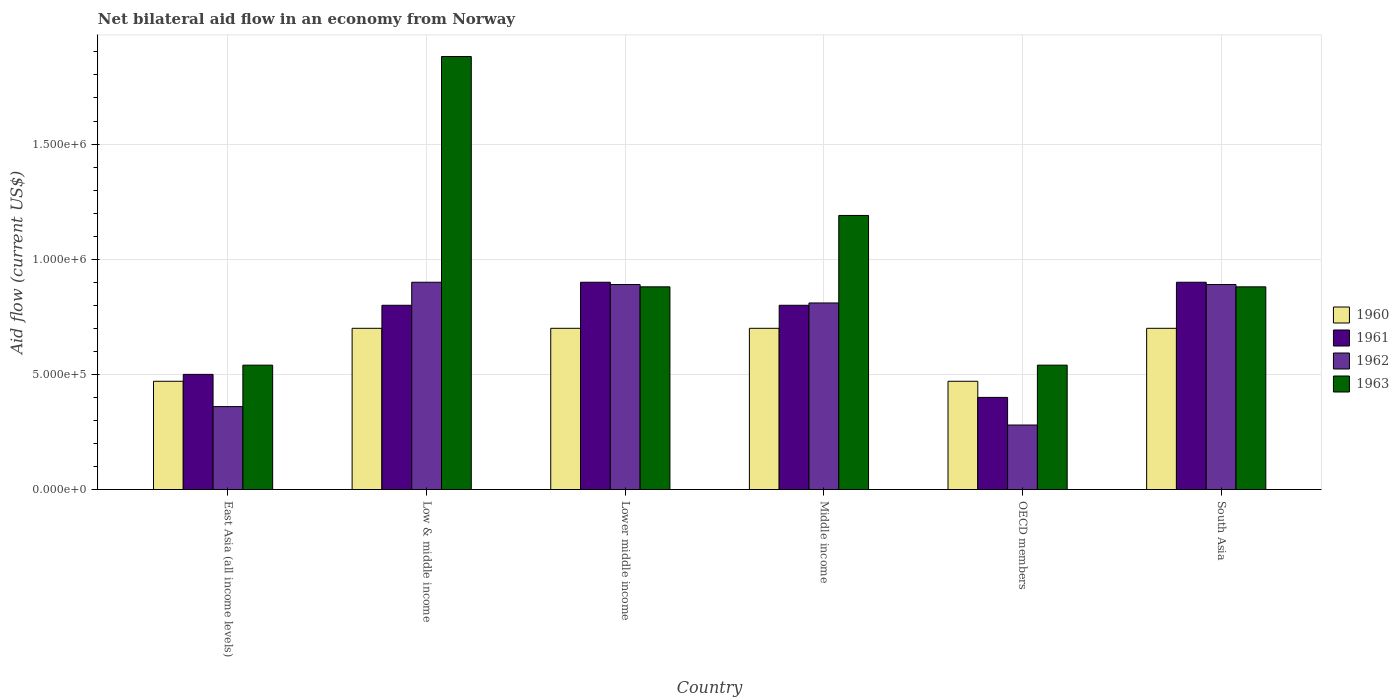How many different coloured bars are there?
Keep it short and to the point. 4. Are the number of bars on each tick of the X-axis equal?
Your answer should be very brief. Yes. What is the label of the 1st group of bars from the left?
Offer a very short reply. East Asia (all income levels). What is the net bilateral aid flow in 1961 in Lower middle income?
Ensure brevity in your answer.  9.00e+05. Across all countries, what is the maximum net bilateral aid flow in 1963?
Keep it short and to the point. 1.88e+06. In which country was the net bilateral aid flow in 1960 minimum?
Your answer should be very brief. East Asia (all income levels). What is the total net bilateral aid flow in 1962 in the graph?
Your answer should be compact. 4.13e+06. What is the difference between the net bilateral aid flow in 1962 in Lower middle income and that in South Asia?
Offer a terse response. 0. What is the average net bilateral aid flow in 1963 per country?
Offer a very short reply. 9.85e+05. What is the difference between the net bilateral aid flow of/in 1962 and net bilateral aid flow of/in 1963 in Middle income?
Your answer should be compact. -3.80e+05. What is the ratio of the net bilateral aid flow in 1962 in East Asia (all income levels) to that in South Asia?
Your answer should be compact. 0.4. What is the difference between the highest and the second highest net bilateral aid flow in 1963?
Your answer should be compact. 6.90e+05. What is the difference between the highest and the lowest net bilateral aid flow in 1960?
Offer a very short reply. 2.30e+05. Is the sum of the net bilateral aid flow in 1961 in Low & middle income and South Asia greater than the maximum net bilateral aid flow in 1963 across all countries?
Ensure brevity in your answer.  No. Is it the case that in every country, the sum of the net bilateral aid flow in 1961 and net bilateral aid flow in 1960 is greater than the sum of net bilateral aid flow in 1963 and net bilateral aid flow in 1962?
Offer a very short reply. No. What does the 4th bar from the left in Middle income represents?
Your response must be concise. 1963. How many bars are there?
Your answer should be compact. 24. How many countries are there in the graph?
Your response must be concise. 6. What is the difference between two consecutive major ticks on the Y-axis?
Provide a short and direct response. 5.00e+05. Does the graph contain any zero values?
Keep it short and to the point. No. How many legend labels are there?
Provide a short and direct response. 4. How are the legend labels stacked?
Your response must be concise. Vertical. What is the title of the graph?
Your response must be concise. Net bilateral aid flow in an economy from Norway. Does "2015" appear as one of the legend labels in the graph?
Your answer should be very brief. No. What is the label or title of the X-axis?
Provide a succinct answer. Country. What is the label or title of the Y-axis?
Provide a short and direct response. Aid flow (current US$). What is the Aid flow (current US$) in 1963 in East Asia (all income levels)?
Offer a terse response. 5.40e+05. What is the Aid flow (current US$) of 1962 in Low & middle income?
Ensure brevity in your answer.  9.00e+05. What is the Aid flow (current US$) of 1963 in Low & middle income?
Your answer should be very brief. 1.88e+06. What is the Aid flow (current US$) in 1962 in Lower middle income?
Keep it short and to the point. 8.90e+05. What is the Aid flow (current US$) of 1963 in Lower middle income?
Provide a succinct answer. 8.80e+05. What is the Aid flow (current US$) of 1961 in Middle income?
Your response must be concise. 8.00e+05. What is the Aid flow (current US$) of 1962 in Middle income?
Offer a terse response. 8.10e+05. What is the Aid flow (current US$) of 1963 in Middle income?
Offer a very short reply. 1.19e+06. What is the Aid flow (current US$) in 1963 in OECD members?
Your answer should be compact. 5.40e+05. What is the Aid flow (current US$) in 1962 in South Asia?
Offer a very short reply. 8.90e+05. What is the Aid flow (current US$) of 1963 in South Asia?
Ensure brevity in your answer.  8.80e+05. Across all countries, what is the maximum Aid flow (current US$) in 1961?
Provide a short and direct response. 9.00e+05. Across all countries, what is the maximum Aid flow (current US$) of 1962?
Offer a very short reply. 9.00e+05. Across all countries, what is the maximum Aid flow (current US$) of 1963?
Provide a succinct answer. 1.88e+06. Across all countries, what is the minimum Aid flow (current US$) of 1963?
Ensure brevity in your answer.  5.40e+05. What is the total Aid flow (current US$) of 1960 in the graph?
Give a very brief answer. 3.74e+06. What is the total Aid flow (current US$) of 1961 in the graph?
Your answer should be very brief. 4.30e+06. What is the total Aid flow (current US$) in 1962 in the graph?
Provide a succinct answer. 4.13e+06. What is the total Aid flow (current US$) of 1963 in the graph?
Provide a succinct answer. 5.91e+06. What is the difference between the Aid flow (current US$) of 1960 in East Asia (all income levels) and that in Low & middle income?
Offer a terse response. -2.30e+05. What is the difference between the Aid flow (current US$) in 1961 in East Asia (all income levels) and that in Low & middle income?
Your response must be concise. -3.00e+05. What is the difference between the Aid flow (current US$) in 1962 in East Asia (all income levels) and that in Low & middle income?
Offer a terse response. -5.40e+05. What is the difference between the Aid flow (current US$) in 1963 in East Asia (all income levels) and that in Low & middle income?
Provide a succinct answer. -1.34e+06. What is the difference between the Aid flow (current US$) of 1961 in East Asia (all income levels) and that in Lower middle income?
Provide a succinct answer. -4.00e+05. What is the difference between the Aid flow (current US$) in 1962 in East Asia (all income levels) and that in Lower middle income?
Provide a short and direct response. -5.30e+05. What is the difference between the Aid flow (current US$) of 1961 in East Asia (all income levels) and that in Middle income?
Provide a succinct answer. -3.00e+05. What is the difference between the Aid flow (current US$) in 1962 in East Asia (all income levels) and that in Middle income?
Ensure brevity in your answer.  -4.50e+05. What is the difference between the Aid flow (current US$) in 1963 in East Asia (all income levels) and that in Middle income?
Your response must be concise. -6.50e+05. What is the difference between the Aid flow (current US$) in 1960 in East Asia (all income levels) and that in OECD members?
Offer a terse response. 0. What is the difference between the Aid flow (current US$) in 1961 in East Asia (all income levels) and that in OECD members?
Give a very brief answer. 1.00e+05. What is the difference between the Aid flow (current US$) in 1963 in East Asia (all income levels) and that in OECD members?
Provide a succinct answer. 0. What is the difference between the Aid flow (current US$) in 1960 in East Asia (all income levels) and that in South Asia?
Your answer should be very brief. -2.30e+05. What is the difference between the Aid flow (current US$) in 1961 in East Asia (all income levels) and that in South Asia?
Provide a short and direct response. -4.00e+05. What is the difference between the Aid flow (current US$) of 1962 in East Asia (all income levels) and that in South Asia?
Provide a short and direct response. -5.30e+05. What is the difference between the Aid flow (current US$) of 1963 in East Asia (all income levels) and that in South Asia?
Provide a succinct answer. -3.40e+05. What is the difference between the Aid flow (current US$) of 1961 in Low & middle income and that in Lower middle income?
Your answer should be compact. -1.00e+05. What is the difference between the Aid flow (current US$) of 1962 in Low & middle income and that in Lower middle income?
Provide a succinct answer. 10000. What is the difference between the Aid flow (current US$) in 1962 in Low & middle income and that in Middle income?
Your answer should be compact. 9.00e+04. What is the difference between the Aid flow (current US$) of 1963 in Low & middle income and that in Middle income?
Your answer should be very brief. 6.90e+05. What is the difference between the Aid flow (current US$) of 1962 in Low & middle income and that in OECD members?
Provide a short and direct response. 6.20e+05. What is the difference between the Aid flow (current US$) in 1963 in Low & middle income and that in OECD members?
Your answer should be very brief. 1.34e+06. What is the difference between the Aid flow (current US$) in 1961 in Low & middle income and that in South Asia?
Provide a succinct answer. -1.00e+05. What is the difference between the Aid flow (current US$) of 1963 in Low & middle income and that in South Asia?
Keep it short and to the point. 1.00e+06. What is the difference between the Aid flow (current US$) in 1960 in Lower middle income and that in Middle income?
Keep it short and to the point. 0. What is the difference between the Aid flow (current US$) in 1962 in Lower middle income and that in Middle income?
Provide a succinct answer. 8.00e+04. What is the difference between the Aid flow (current US$) in 1963 in Lower middle income and that in Middle income?
Ensure brevity in your answer.  -3.10e+05. What is the difference between the Aid flow (current US$) of 1961 in Lower middle income and that in OECD members?
Provide a succinct answer. 5.00e+05. What is the difference between the Aid flow (current US$) in 1962 in Lower middle income and that in OECD members?
Your answer should be compact. 6.10e+05. What is the difference between the Aid flow (current US$) of 1960 in Lower middle income and that in South Asia?
Keep it short and to the point. 0. What is the difference between the Aid flow (current US$) in 1963 in Lower middle income and that in South Asia?
Your response must be concise. 0. What is the difference between the Aid flow (current US$) of 1960 in Middle income and that in OECD members?
Provide a succinct answer. 2.30e+05. What is the difference between the Aid flow (current US$) in 1961 in Middle income and that in OECD members?
Provide a succinct answer. 4.00e+05. What is the difference between the Aid flow (current US$) in 1962 in Middle income and that in OECD members?
Your response must be concise. 5.30e+05. What is the difference between the Aid flow (current US$) in 1963 in Middle income and that in OECD members?
Give a very brief answer. 6.50e+05. What is the difference between the Aid flow (current US$) of 1962 in Middle income and that in South Asia?
Offer a very short reply. -8.00e+04. What is the difference between the Aid flow (current US$) in 1963 in Middle income and that in South Asia?
Offer a very short reply. 3.10e+05. What is the difference between the Aid flow (current US$) of 1961 in OECD members and that in South Asia?
Your response must be concise. -5.00e+05. What is the difference between the Aid flow (current US$) of 1962 in OECD members and that in South Asia?
Make the answer very short. -6.10e+05. What is the difference between the Aid flow (current US$) of 1963 in OECD members and that in South Asia?
Offer a very short reply. -3.40e+05. What is the difference between the Aid flow (current US$) of 1960 in East Asia (all income levels) and the Aid flow (current US$) of 1961 in Low & middle income?
Provide a succinct answer. -3.30e+05. What is the difference between the Aid flow (current US$) of 1960 in East Asia (all income levels) and the Aid flow (current US$) of 1962 in Low & middle income?
Offer a very short reply. -4.30e+05. What is the difference between the Aid flow (current US$) of 1960 in East Asia (all income levels) and the Aid flow (current US$) of 1963 in Low & middle income?
Offer a very short reply. -1.41e+06. What is the difference between the Aid flow (current US$) in 1961 in East Asia (all income levels) and the Aid flow (current US$) in 1962 in Low & middle income?
Give a very brief answer. -4.00e+05. What is the difference between the Aid flow (current US$) of 1961 in East Asia (all income levels) and the Aid flow (current US$) of 1963 in Low & middle income?
Your response must be concise. -1.38e+06. What is the difference between the Aid flow (current US$) in 1962 in East Asia (all income levels) and the Aid flow (current US$) in 1963 in Low & middle income?
Give a very brief answer. -1.52e+06. What is the difference between the Aid flow (current US$) in 1960 in East Asia (all income levels) and the Aid flow (current US$) in 1961 in Lower middle income?
Give a very brief answer. -4.30e+05. What is the difference between the Aid flow (current US$) of 1960 in East Asia (all income levels) and the Aid flow (current US$) of 1962 in Lower middle income?
Provide a short and direct response. -4.20e+05. What is the difference between the Aid flow (current US$) in 1960 in East Asia (all income levels) and the Aid flow (current US$) in 1963 in Lower middle income?
Your answer should be compact. -4.10e+05. What is the difference between the Aid flow (current US$) of 1961 in East Asia (all income levels) and the Aid flow (current US$) of 1962 in Lower middle income?
Your answer should be compact. -3.90e+05. What is the difference between the Aid flow (current US$) of 1961 in East Asia (all income levels) and the Aid flow (current US$) of 1963 in Lower middle income?
Ensure brevity in your answer.  -3.80e+05. What is the difference between the Aid flow (current US$) of 1962 in East Asia (all income levels) and the Aid flow (current US$) of 1963 in Lower middle income?
Your answer should be very brief. -5.20e+05. What is the difference between the Aid flow (current US$) in 1960 in East Asia (all income levels) and the Aid flow (current US$) in 1961 in Middle income?
Offer a terse response. -3.30e+05. What is the difference between the Aid flow (current US$) of 1960 in East Asia (all income levels) and the Aid flow (current US$) of 1963 in Middle income?
Your response must be concise. -7.20e+05. What is the difference between the Aid flow (current US$) in 1961 in East Asia (all income levels) and the Aid flow (current US$) in 1962 in Middle income?
Ensure brevity in your answer.  -3.10e+05. What is the difference between the Aid flow (current US$) in 1961 in East Asia (all income levels) and the Aid flow (current US$) in 1963 in Middle income?
Your response must be concise. -6.90e+05. What is the difference between the Aid flow (current US$) in 1962 in East Asia (all income levels) and the Aid flow (current US$) in 1963 in Middle income?
Provide a short and direct response. -8.30e+05. What is the difference between the Aid flow (current US$) in 1960 in East Asia (all income levels) and the Aid flow (current US$) in 1961 in OECD members?
Offer a very short reply. 7.00e+04. What is the difference between the Aid flow (current US$) in 1961 in East Asia (all income levels) and the Aid flow (current US$) in 1962 in OECD members?
Offer a terse response. 2.20e+05. What is the difference between the Aid flow (current US$) in 1961 in East Asia (all income levels) and the Aid flow (current US$) in 1963 in OECD members?
Provide a short and direct response. -4.00e+04. What is the difference between the Aid flow (current US$) in 1962 in East Asia (all income levels) and the Aid flow (current US$) in 1963 in OECD members?
Give a very brief answer. -1.80e+05. What is the difference between the Aid flow (current US$) in 1960 in East Asia (all income levels) and the Aid flow (current US$) in 1961 in South Asia?
Keep it short and to the point. -4.30e+05. What is the difference between the Aid flow (current US$) in 1960 in East Asia (all income levels) and the Aid flow (current US$) in 1962 in South Asia?
Keep it short and to the point. -4.20e+05. What is the difference between the Aid flow (current US$) in 1960 in East Asia (all income levels) and the Aid flow (current US$) in 1963 in South Asia?
Make the answer very short. -4.10e+05. What is the difference between the Aid flow (current US$) of 1961 in East Asia (all income levels) and the Aid flow (current US$) of 1962 in South Asia?
Your answer should be compact. -3.90e+05. What is the difference between the Aid flow (current US$) in 1961 in East Asia (all income levels) and the Aid flow (current US$) in 1963 in South Asia?
Keep it short and to the point. -3.80e+05. What is the difference between the Aid flow (current US$) in 1962 in East Asia (all income levels) and the Aid flow (current US$) in 1963 in South Asia?
Your response must be concise. -5.20e+05. What is the difference between the Aid flow (current US$) of 1961 in Low & middle income and the Aid flow (current US$) of 1963 in Lower middle income?
Offer a very short reply. -8.00e+04. What is the difference between the Aid flow (current US$) in 1962 in Low & middle income and the Aid flow (current US$) in 1963 in Lower middle income?
Ensure brevity in your answer.  2.00e+04. What is the difference between the Aid flow (current US$) in 1960 in Low & middle income and the Aid flow (current US$) in 1963 in Middle income?
Your response must be concise. -4.90e+05. What is the difference between the Aid flow (current US$) of 1961 in Low & middle income and the Aid flow (current US$) of 1962 in Middle income?
Offer a terse response. -10000. What is the difference between the Aid flow (current US$) in 1961 in Low & middle income and the Aid flow (current US$) in 1963 in Middle income?
Offer a very short reply. -3.90e+05. What is the difference between the Aid flow (current US$) in 1962 in Low & middle income and the Aid flow (current US$) in 1963 in Middle income?
Your answer should be compact. -2.90e+05. What is the difference between the Aid flow (current US$) in 1960 in Low & middle income and the Aid flow (current US$) in 1961 in OECD members?
Provide a succinct answer. 3.00e+05. What is the difference between the Aid flow (current US$) of 1960 in Low & middle income and the Aid flow (current US$) of 1963 in OECD members?
Offer a terse response. 1.60e+05. What is the difference between the Aid flow (current US$) of 1961 in Low & middle income and the Aid flow (current US$) of 1962 in OECD members?
Your answer should be compact. 5.20e+05. What is the difference between the Aid flow (current US$) of 1960 in Low & middle income and the Aid flow (current US$) of 1963 in South Asia?
Keep it short and to the point. -1.80e+05. What is the difference between the Aid flow (current US$) in 1962 in Low & middle income and the Aid flow (current US$) in 1963 in South Asia?
Your answer should be very brief. 2.00e+04. What is the difference between the Aid flow (current US$) of 1960 in Lower middle income and the Aid flow (current US$) of 1961 in Middle income?
Your answer should be very brief. -1.00e+05. What is the difference between the Aid flow (current US$) in 1960 in Lower middle income and the Aid flow (current US$) in 1962 in Middle income?
Offer a very short reply. -1.10e+05. What is the difference between the Aid flow (current US$) of 1960 in Lower middle income and the Aid flow (current US$) of 1963 in Middle income?
Ensure brevity in your answer.  -4.90e+05. What is the difference between the Aid flow (current US$) of 1961 in Lower middle income and the Aid flow (current US$) of 1962 in Middle income?
Keep it short and to the point. 9.00e+04. What is the difference between the Aid flow (current US$) in 1961 in Lower middle income and the Aid flow (current US$) in 1963 in Middle income?
Your answer should be compact. -2.90e+05. What is the difference between the Aid flow (current US$) of 1960 in Lower middle income and the Aid flow (current US$) of 1961 in OECD members?
Provide a succinct answer. 3.00e+05. What is the difference between the Aid flow (current US$) of 1960 in Lower middle income and the Aid flow (current US$) of 1962 in OECD members?
Your response must be concise. 4.20e+05. What is the difference between the Aid flow (current US$) in 1960 in Lower middle income and the Aid flow (current US$) in 1963 in OECD members?
Keep it short and to the point. 1.60e+05. What is the difference between the Aid flow (current US$) of 1961 in Lower middle income and the Aid flow (current US$) of 1962 in OECD members?
Give a very brief answer. 6.20e+05. What is the difference between the Aid flow (current US$) in 1962 in Lower middle income and the Aid flow (current US$) in 1963 in OECD members?
Keep it short and to the point. 3.50e+05. What is the difference between the Aid flow (current US$) of 1960 in Lower middle income and the Aid flow (current US$) of 1961 in South Asia?
Offer a terse response. -2.00e+05. What is the difference between the Aid flow (current US$) in 1960 in Lower middle income and the Aid flow (current US$) in 1962 in South Asia?
Make the answer very short. -1.90e+05. What is the difference between the Aid flow (current US$) of 1960 in Lower middle income and the Aid flow (current US$) of 1963 in South Asia?
Offer a very short reply. -1.80e+05. What is the difference between the Aid flow (current US$) of 1961 in Lower middle income and the Aid flow (current US$) of 1962 in South Asia?
Ensure brevity in your answer.  10000. What is the difference between the Aid flow (current US$) of 1961 in Lower middle income and the Aid flow (current US$) of 1963 in South Asia?
Your answer should be very brief. 2.00e+04. What is the difference between the Aid flow (current US$) of 1962 in Lower middle income and the Aid flow (current US$) of 1963 in South Asia?
Give a very brief answer. 10000. What is the difference between the Aid flow (current US$) in 1961 in Middle income and the Aid flow (current US$) in 1962 in OECD members?
Provide a succinct answer. 5.20e+05. What is the difference between the Aid flow (current US$) of 1961 in Middle income and the Aid flow (current US$) of 1963 in OECD members?
Your response must be concise. 2.60e+05. What is the difference between the Aid flow (current US$) in 1960 in Middle income and the Aid flow (current US$) in 1961 in South Asia?
Keep it short and to the point. -2.00e+05. What is the difference between the Aid flow (current US$) in 1961 in Middle income and the Aid flow (current US$) in 1962 in South Asia?
Offer a terse response. -9.00e+04. What is the difference between the Aid flow (current US$) of 1961 in Middle income and the Aid flow (current US$) of 1963 in South Asia?
Give a very brief answer. -8.00e+04. What is the difference between the Aid flow (current US$) of 1960 in OECD members and the Aid flow (current US$) of 1961 in South Asia?
Offer a terse response. -4.30e+05. What is the difference between the Aid flow (current US$) of 1960 in OECD members and the Aid flow (current US$) of 1962 in South Asia?
Keep it short and to the point. -4.20e+05. What is the difference between the Aid flow (current US$) of 1960 in OECD members and the Aid flow (current US$) of 1963 in South Asia?
Offer a terse response. -4.10e+05. What is the difference between the Aid flow (current US$) of 1961 in OECD members and the Aid flow (current US$) of 1962 in South Asia?
Provide a short and direct response. -4.90e+05. What is the difference between the Aid flow (current US$) of 1961 in OECD members and the Aid flow (current US$) of 1963 in South Asia?
Provide a short and direct response. -4.80e+05. What is the difference between the Aid flow (current US$) of 1962 in OECD members and the Aid flow (current US$) of 1963 in South Asia?
Offer a terse response. -6.00e+05. What is the average Aid flow (current US$) of 1960 per country?
Give a very brief answer. 6.23e+05. What is the average Aid flow (current US$) of 1961 per country?
Your response must be concise. 7.17e+05. What is the average Aid flow (current US$) of 1962 per country?
Provide a succinct answer. 6.88e+05. What is the average Aid flow (current US$) in 1963 per country?
Offer a very short reply. 9.85e+05. What is the difference between the Aid flow (current US$) in 1960 and Aid flow (current US$) in 1963 in East Asia (all income levels)?
Your answer should be very brief. -7.00e+04. What is the difference between the Aid flow (current US$) in 1960 and Aid flow (current US$) in 1961 in Low & middle income?
Offer a very short reply. -1.00e+05. What is the difference between the Aid flow (current US$) of 1960 and Aid flow (current US$) of 1963 in Low & middle income?
Provide a short and direct response. -1.18e+06. What is the difference between the Aid flow (current US$) of 1961 and Aid flow (current US$) of 1963 in Low & middle income?
Provide a short and direct response. -1.08e+06. What is the difference between the Aid flow (current US$) in 1962 and Aid flow (current US$) in 1963 in Low & middle income?
Offer a terse response. -9.80e+05. What is the difference between the Aid flow (current US$) of 1960 and Aid flow (current US$) of 1961 in Lower middle income?
Your answer should be compact. -2.00e+05. What is the difference between the Aid flow (current US$) of 1960 and Aid flow (current US$) of 1962 in Lower middle income?
Your response must be concise. -1.90e+05. What is the difference between the Aid flow (current US$) in 1960 and Aid flow (current US$) in 1963 in Middle income?
Keep it short and to the point. -4.90e+05. What is the difference between the Aid flow (current US$) of 1961 and Aid flow (current US$) of 1962 in Middle income?
Keep it short and to the point. -10000. What is the difference between the Aid flow (current US$) in 1961 and Aid flow (current US$) in 1963 in Middle income?
Offer a terse response. -3.90e+05. What is the difference between the Aid flow (current US$) in 1962 and Aid flow (current US$) in 1963 in Middle income?
Give a very brief answer. -3.80e+05. What is the difference between the Aid flow (current US$) in 1960 and Aid flow (current US$) in 1961 in OECD members?
Ensure brevity in your answer.  7.00e+04. What is the difference between the Aid flow (current US$) in 1960 and Aid flow (current US$) in 1962 in OECD members?
Give a very brief answer. 1.90e+05. What is the difference between the Aid flow (current US$) in 1961 and Aid flow (current US$) in 1962 in OECD members?
Make the answer very short. 1.20e+05. What is the difference between the Aid flow (current US$) of 1961 and Aid flow (current US$) of 1963 in OECD members?
Provide a succinct answer. -1.40e+05. What is the difference between the Aid flow (current US$) in 1962 and Aid flow (current US$) in 1963 in OECD members?
Your answer should be compact. -2.60e+05. What is the difference between the Aid flow (current US$) in 1960 and Aid flow (current US$) in 1962 in South Asia?
Your response must be concise. -1.90e+05. What is the difference between the Aid flow (current US$) of 1961 and Aid flow (current US$) of 1963 in South Asia?
Your answer should be very brief. 2.00e+04. What is the difference between the Aid flow (current US$) in 1962 and Aid flow (current US$) in 1963 in South Asia?
Your answer should be compact. 10000. What is the ratio of the Aid flow (current US$) of 1960 in East Asia (all income levels) to that in Low & middle income?
Keep it short and to the point. 0.67. What is the ratio of the Aid flow (current US$) in 1961 in East Asia (all income levels) to that in Low & middle income?
Offer a very short reply. 0.62. What is the ratio of the Aid flow (current US$) in 1962 in East Asia (all income levels) to that in Low & middle income?
Your answer should be compact. 0.4. What is the ratio of the Aid flow (current US$) of 1963 in East Asia (all income levels) to that in Low & middle income?
Offer a very short reply. 0.29. What is the ratio of the Aid flow (current US$) in 1960 in East Asia (all income levels) to that in Lower middle income?
Provide a succinct answer. 0.67. What is the ratio of the Aid flow (current US$) of 1961 in East Asia (all income levels) to that in Lower middle income?
Offer a very short reply. 0.56. What is the ratio of the Aid flow (current US$) of 1962 in East Asia (all income levels) to that in Lower middle income?
Your answer should be compact. 0.4. What is the ratio of the Aid flow (current US$) of 1963 in East Asia (all income levels) to that in Lower middle income?
Your response must be concise. 0.61. What is the ratio of the Aid flow (current US$) of 1960 in East Asia (all income levels) to that in Middle income?
Make the answer very short. 0.67. What is the ratio of the Aid flow (current US$) of 1961 in East Asia (all income levels) to that in Middle income?
Offer a very short reply. 0.62. What is the ratio of the Aid flow (current US$) of 1962 in East Asia (all income levels) to that in Middle income?
Provide a succinct answer. 0.44. What is the ratio of the Aid flow (current US$) of 1963 in East Asia (all income levels) to that in Middle income?
Make the answer very short. 0.45. What is the ratio of the Aid flow (current US$) of 1960 in East Asia (all income levels) to that in OECD members?
Your answer should be very brief. 1. What is the ratio of the Aid flow (current US$) in 1962 in East Asia (all income levels) to that in OECD members?
Ensure brevity in your answer.  1.29. What is the ratio of the Aid flow (current US$) in 1960 in East Asia (all income levels) to that in South Asia?
Your response must be concise. 0.67. What is the ratio of the Aid flow (current US$) of 1961 in East Asia (all income levels) to that in South Asia?
Your response must be concise. 0.56. What is the ratio of the Aid flow (current US$) in 1962 in East Asia (all income levels) to that in South Asia?
Your response must be concise. 0.4. What is the ratio of the Aid flow (current US$) of 1963 in East Asia (all income levels) to that in South Asia?
Provide a succinct answer. 0.61. What is the ratio of the Aid flow (current US$) of 1962 in Low & middle income to that in Lower middle income?
Offer a very short reply. 1.01. What is the ratio of the Aid flow (current US$) in 1963 in Low & middle income to that in Lower middle income?
Provide a succinct answer. 2.14. What is the ratio of the Aid flow (current US$) of 1961 in Low & middle income to that in Middle income?
Ensure brevity in your answer.  1. What is the ratio of the Aid flow (current US$) of 1963 in Low & middle income to that in Middle income?
Your response must be concise. 1.58. What is the ratio of the Aid flow (current US$) in 1960 in Low & middle income to that in OECD members?
Provide a succinct answer. 1.49. What is the ratio of the Aid flow (current US$) of 1962 in Low & middle income to that in OECD members?
Make the answer very short. 3.21. What is the ratio of the Aid flow (current US$) in 1963 in Low & middle income to that in OECD members?
Offer a very short reply. 3.48. What is the ratio of the Aid flow (current US$) in 1962 in Low & middle income to that in South Asia?
Provide a short and direct response. 1.01. What is the ratio of the Aid flow (current US$) of 1963 in Low & middle income to that in South Asia?
Offer a terse response. 2.14. What is the ratio of the Aid flow (current US$) in 1960 in Lower middle income to that in Middle income?
Offer a terse response. 1. What is the ratio of the Aid flow (current US$) of 1961 in Lower middle income to that in Middle income?
Your response must be concise. 1.12. What is the ratio of the Aid flow (current US$) of 1962 in Lower middle income to that in Middle income?
Provide a succinct answer. 1.1. What is the ratio of the Aid flow (current US$) of 1963 in Lower middle income to that in Middle income?
Your response must be concise. 0.74. What is the ratio of the Aid flow (current US$) in 1960 in Lower middle income to that in OECD members?
Offer a very short reply. 1.49. What is the ratio of the Aid flow (current US$) of 1961 in Lower middle income to that in OECD members?
Your answer should be compact. 2.25. What is the ratio of the Aid flow (current US$) in 1962 in Lower middle income to that in OECD members?
Make the answer very short. 3.18. What is the ratio of the Aid flow (current US$) in 1963 in Lower middle income to that in OECD members?
Ensure brevity in your answer.  1.63. What is the ratio of the Aid flow (current US$) in 1960 in Middle income to that in OECD members?
Provide a succinct answer. 1.49. What is the ratio of the Aid flow (current US$) of 1962 in Middle income to that in OECD members?
Make the answer very short. 2.89. What is the ratio of the Aid flow (current US$) of 1963 in Middle income to that in OECD members?
Keep it short and to the point. 2.2. What is the ratio of the Aid flow (current US$) of 1962 in Middle income to that in South Asia?
Your response must be concise. 0.91. What is the ratio of the Aid flow (current US$) of 1963 in Middle income to that in South Asia?
Your answer should be compact. 1.35. What is the ratio of the Aid flow (current US$) in 1960 in OECD members to that in South Asia?
Provide a short and direct response. 0.67. What is the ratio of the Aid flow (current US$) in 1961 in OECD members to that in South Asia?
Your answer should be compact. 0.44. What is the ratio of the Aid flow (current US$) of 1962 in OECD members to that in South Asia?
Offer a terse response. 0.31. What is the ratio of the Aid flow (current US$) in 1963 in OECD members to that in South Asia?
Provide a succinct answer. 0.61. What is the difference between the highest and the second highest Aid flow (current US$) in 1961?
Your answer should be compact. 0. What is the difference between the highest and the second highest Aid flow (current US$) in 1962?
Your answer should be very brief. 10000. What is the difference between the highest and the second highest Aid flow (current US$) of 1963?
Offer a terse response. 6.90e+05. What is the difference between the highest and the lowest Aid flow (current US$) of 1960?
Your answer should be very brief. 2.30e+05. What is the difference between the highest and the lowest Aid flow (current US$) in 1962?
Ensure brevity in your answer.  6.20e+05. What is the difference between the highest and the lowest Aid flow (current US$) in 1963?
Ensure brevity in your answer.  1.34e+06. 